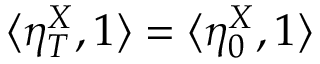<formula> <loc_0><loc_0><loc_500><loc_500>\langle \eta _ { T } ^ { X } , 1 \rangle = \langle \eta _ { 0 } ^ { X } , 1 \rangle</formula> 